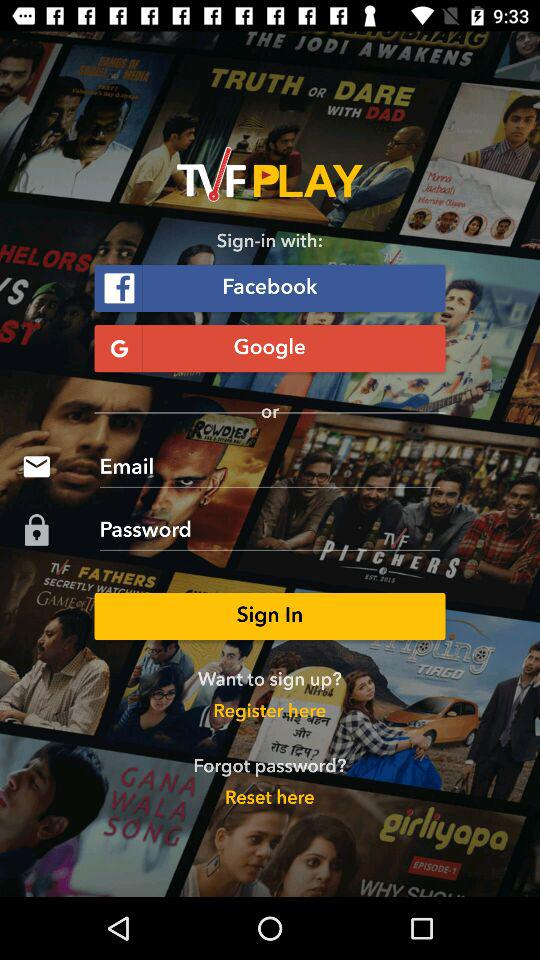What options are available to sign in? The available options are "Facebook", "Google" and "Email". 